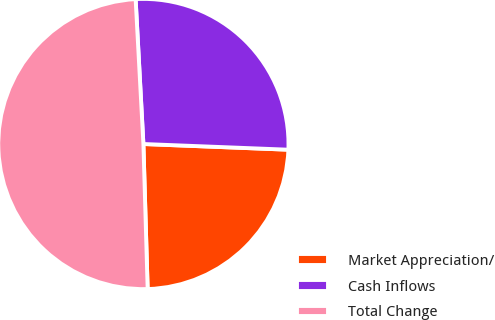<chart> <loc_0><loc_0><loc_500><loc_500><pie_chart><fcel>Market Appreciation/<fcel>Cash Inflows<fcel>Total Change<nl><fcel>23.91%<fcel>26.48%<fcel>49.62%<nl></chart> 